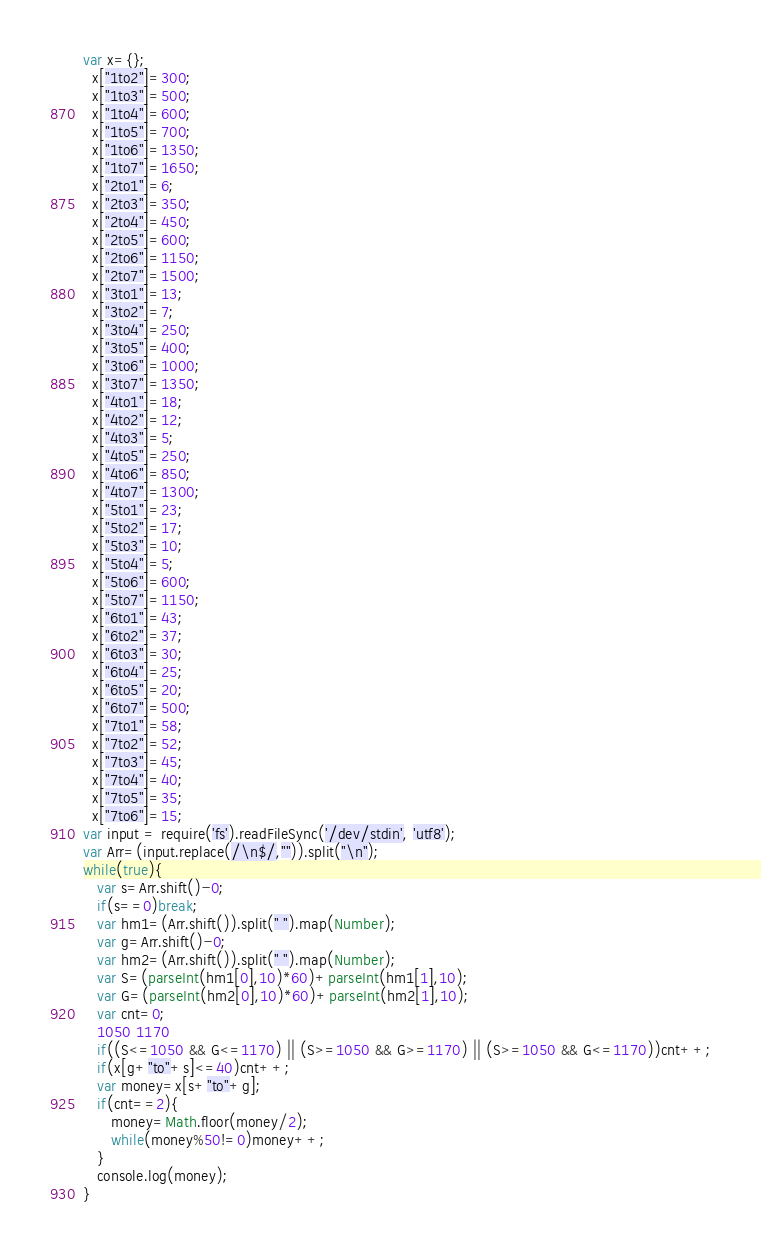Convert code to text. <code><loc_0><loc_0><loc_500><loc_500><_JavaScript_>var x={};
  x["1to2"]=300;
  x["1to3"]=500;
  x["1to4"]=600;
  x["1to5"]=700;
  x["1to6"]=1350;
  x["1to7"]=1650;
  x["2to1"]=6;
  x["2to3"]=350;
  x["2to4"]=450;
  x["2to5"]=600;
  x["2to6"]=1150;  
  x["2to7"]=1500;
  x["3to1"]=13;
  x["3to2"]=7;
  x["3to4"]=250;
  x["3to5"]=400;
  x["3to6"]=1000;
  x["3to7"]=1350;
  x["4to1"]=18;
  x["4to2"]=12;
  x["4to3"]=5;
  x["4to5"]=250;
  x["4to6"]=850;
  x["4to7"]=1300;
  x["5to1"]=23;
  x["5to2"]=17;
  x["5to3"]=10;
  x["5to4"]=5;
  x["5to6"]=600;
  x["5to7"]=1150;
  x["6to1"]=43;
  x["6to2"]=37;
  x["6to3"]=30;
  x["6to4"]=25;
  x["6to5"]=20;
  x["6to7"]=500;
  x["7to1"]=58;
  x["7to2"]=52;
  x["7to3"]=45;
  x["7to4"]=40;
  x["7to5"]=35;
  x["7to6"]=15;
var input = require('fs').readFileSync('/dev/stdin', 'utf8');
var Arr=(input.replace(/\n$/,"")).split("\n");
while(true){
   var s=Arr.shift()-0;
   if(s==0)break;
   var hm1=(Arr.shift()).split(" ").map(Number);
   var g=Arr.shift()-0;
   var hm2=(Arr.shift()).split(" ").map(Number);
   var S=(parseInt(hm1[0],10)*60)+parseInt(hm1[1],10);
   var G=(parseInt(hm2[0],10)*60)+parseInt(hm2[1],10);
   var cnt=0;
   1050 1170
   if((S<=1050 && G<=1170) || (S>=1050 && G>=1170) || (S>=1050 && G<=1170))cnt++;
   if(x[g+"to"+s]<=40)cnt++;
   var money=x[s+"to"+g];
   if(cnt==2){
      money=Math.floor(money/2);
      while(money%50!=0)money++;
   }
   console.log(money);
}</code> 